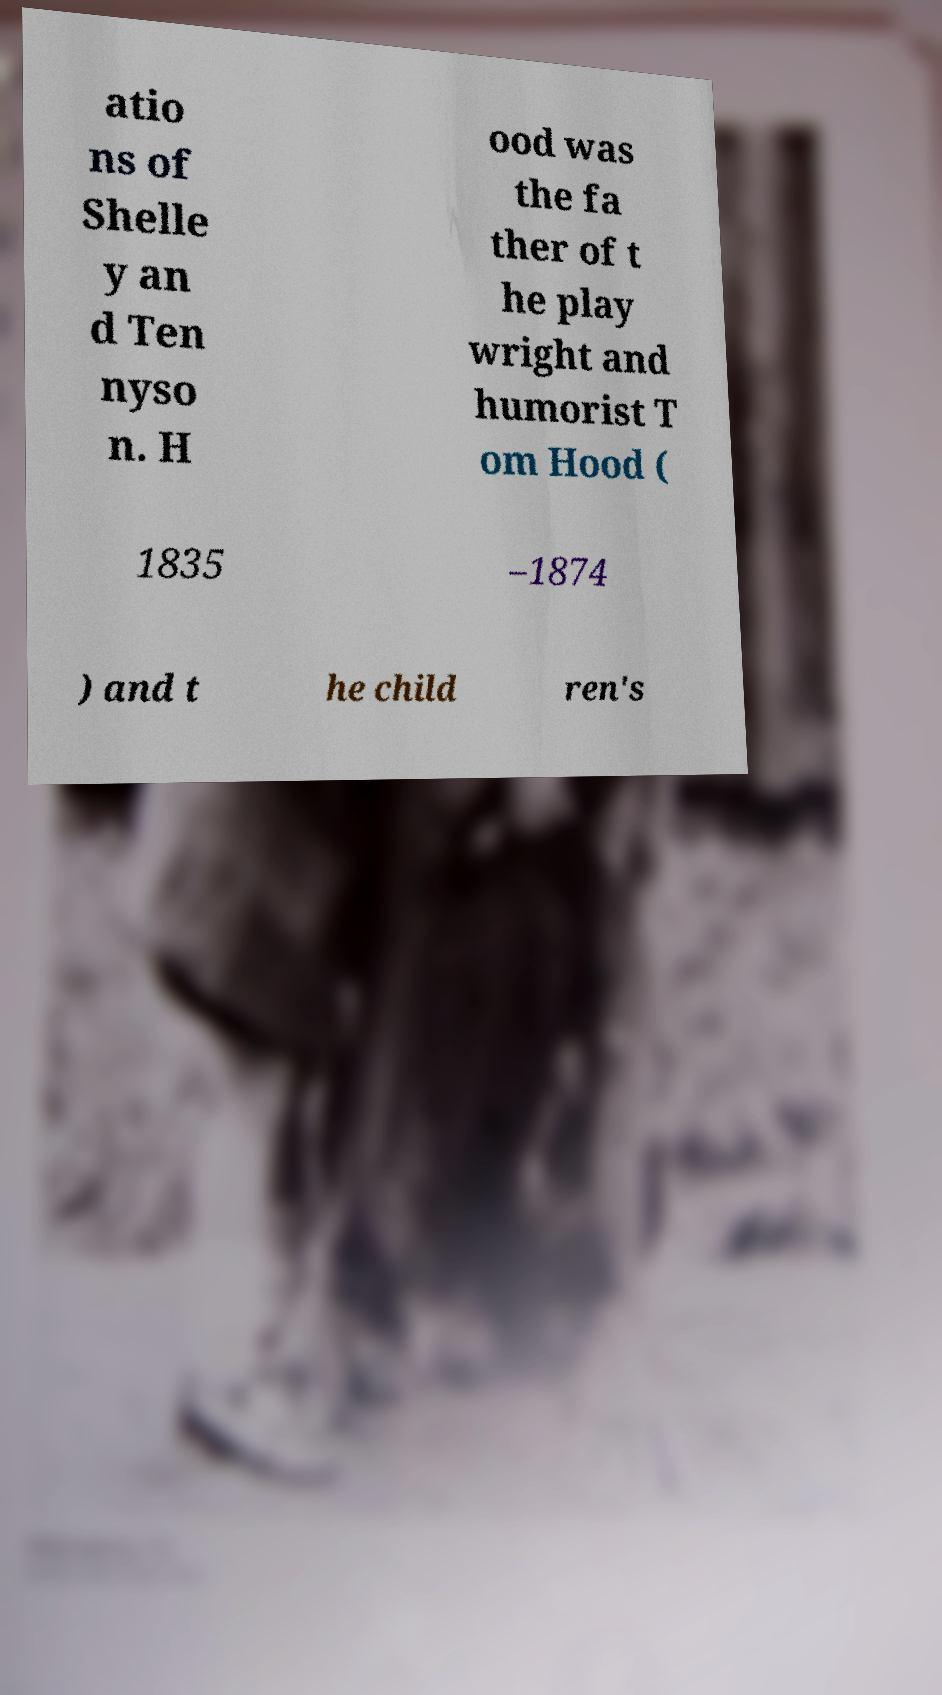Please read and relay the text visible in this image. What does it say? atio ns of Shelle y an d Ten nyso n. H ood was the fa ther of t he play wright and humorist T om Hood ( 1835 –1874 ) and t he child ren's 